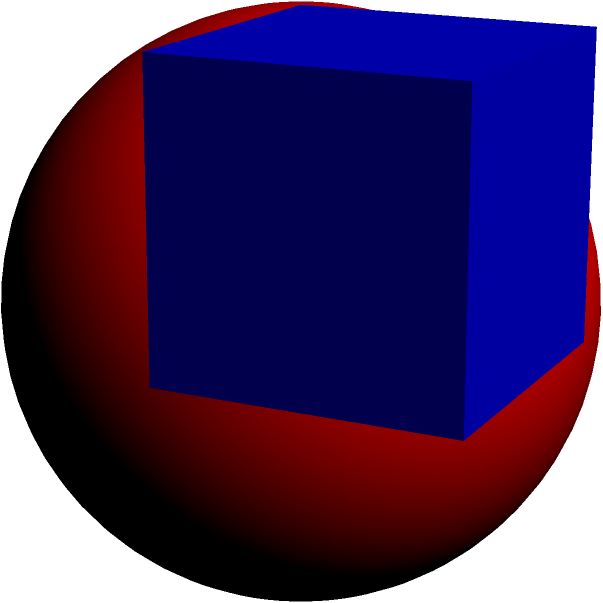In a collaborative educational program, you're tasked with creating a geometry lesson that bridges secular and religious contexts. Given a cube with an edge length of 12 cm, calculate the volume of the largest sphere that can be inscribed within this cube. How might this concept be used to discuss the relationship between containing structures and inner potential in both secular and religious contexts? Let's approach this step-by-step:

1) In a cube with an inscribed sphere, the diameter of the sphere is equal to the length of the cube's edge. This is because the sphere touches the cube at the center of each face.

2) Given:
   - Cube edge length = 12 cm
   - Sphere diameter = 12 cm
   - Sphere radius = 12/2 = 6 cm

3) The volume of a sphere is given by the formula:
   $$V = \frac{4}{3}\pi r^3$$

4) Substituting the radius:
   $$V = \frac{4}{3}\pi (6 \text{ cm})^3$$

5) Simplifying:
   $$V = \frac{4}{3}\pi (216 \text{ cm}^3)$$
   $$V = 288\pi \text{ cm}^3$$

6) Calculating the final value (rounded to two decimal places):
   $$V \approx 904.78 \text{ cm}^3$$

This concept can be used to discuss how structures (like educational systems or religious institutions) can provide a framework (the cube) within which individual potential (the sphere) can develop to its fullest extent while still being supported and contained.
Answer: $904.78 \text{ cm}^3$ 